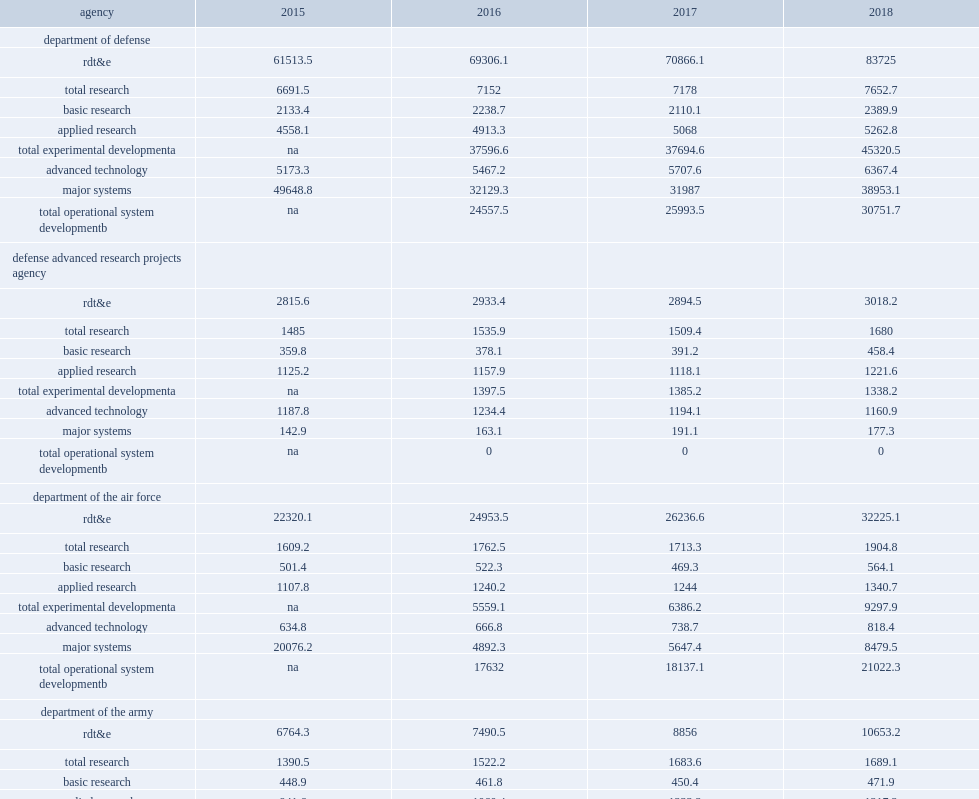How many dollars did osd obligations increase to in fy 2018? 30751.7. 